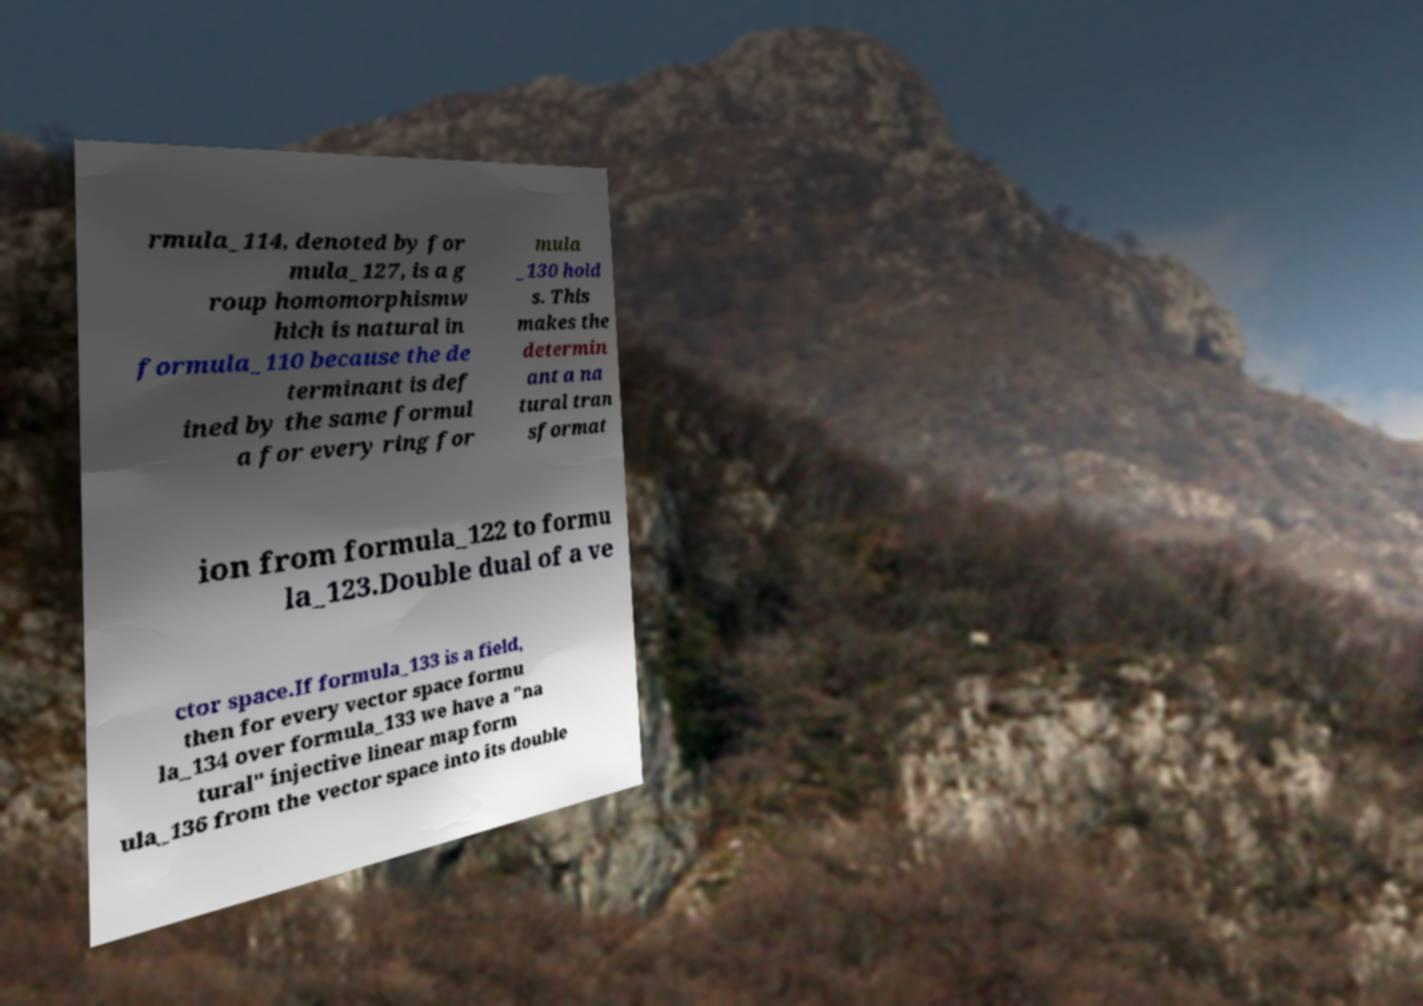Could you assist in decoding the text presented in this image and type it out clearly? rmula_114, denoted by for mula_127, is a g roup homomorphismw hich is natural in formula_110 because the de terminant is def ined by the same formul a for every ring for mula _130 hold s. This makes the determin ant a na tural tran sformat ion from formula_122 to formu la_123.Double dual of a ve ctor space.If formula_133 is a field, then for every vector space formu la_134 over formula_133 we have a "na tural" injective linear map form ula_136 from the vector space into its double 